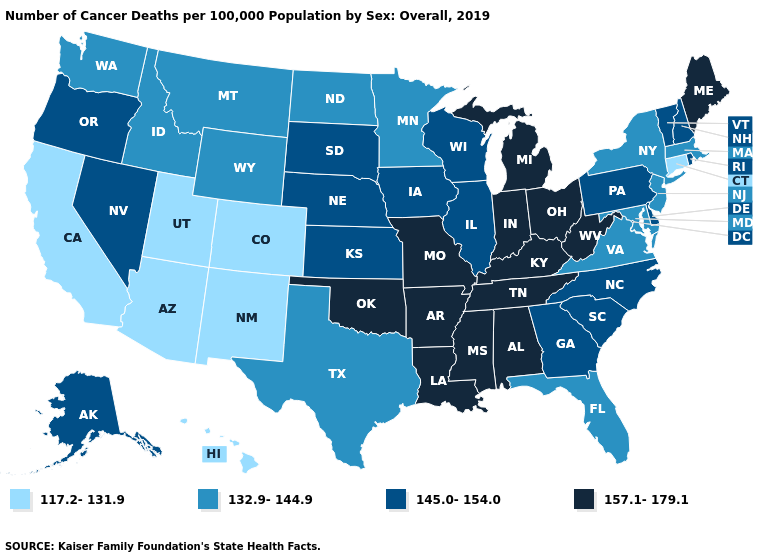Among the states that border Delaware , does New Jersey have the highest value?
Concise answer only. No. What is the value of Hawaii?
Be succinct. 117.2-131.9. What is the value of Delaware?
Write a very short answer. 145.0-154.0. Name the states that have a value in the range 132.9-144.9?
Answer briefly. Florida, Idaho, Maryland, Massachusetts, Minnesota, Montana, New Jersey, New York, North Dakota, Texas, Virginia, Washington, Wyoming. Does the first symbol in the legend represent the smallest category?
Write a very short answer. Yes. What is the value of Michigan?
Concise answer only. 157.1-179.1. Does Alabama have the lowest value in the South?
Keep it brief. No. Does the first symbol in the legend represent the smallest category?
Write a very short answer. Yes. Which states have the lowest value in the USA?
Give a very brief answer. Arizona, California, Colorado, Connecticut, Hawaii, New Mexico, Utah. Does Utah have the same value as California?
Quick response, please. Yes. Does Rhode Island have the lowest value in the Northeast?
Quick response, please. No. Does Illinois have a lower value than Wyoming?
Keep it brief. No. What is the highest value in the USA?
Short answer required. 157.1-179.1. Which states have the lowest value in the Northeast?
Quick response, please. Connecticut. Name the states that have a value in the range 117.2-131.9?
Concise answer only. Arizona, California, Colorado, Connecticut, Hawaii, New Mexico, Utah. 